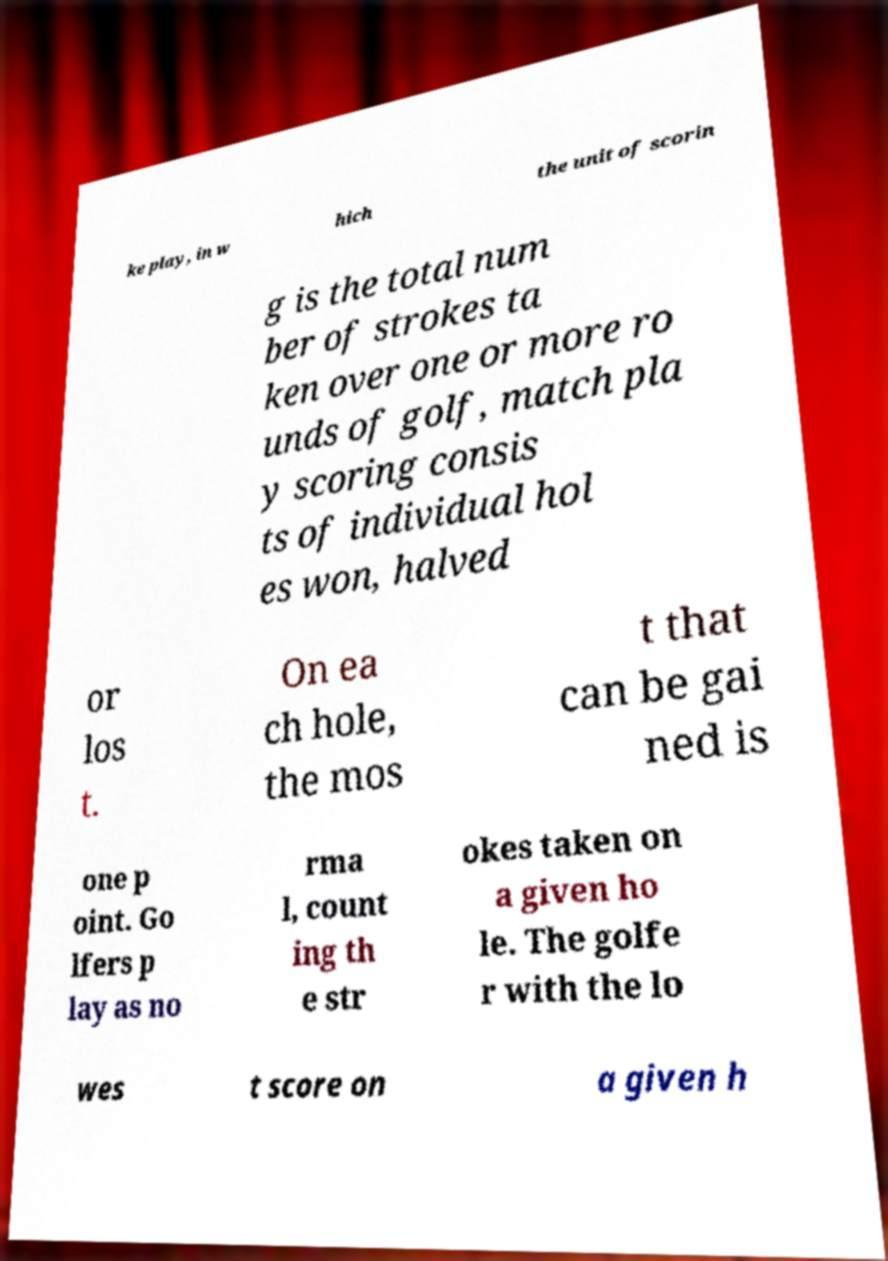There's text embedded in this image that I need extracted. Can you transcribe it verbatim? ke play, in w hich the unit of scorin g is the total num ber of strokes ta ken over one or more ro unds of golf, match pla y scoring consis ts of individual hol es won, halved or los t. On ea ch hole, the mos t that can be gai ned is one p oint. Go lfers p lay as no rma l, count ing th e str okes taken on a given ho le. The golfe r with the lo wes t score on a given h 